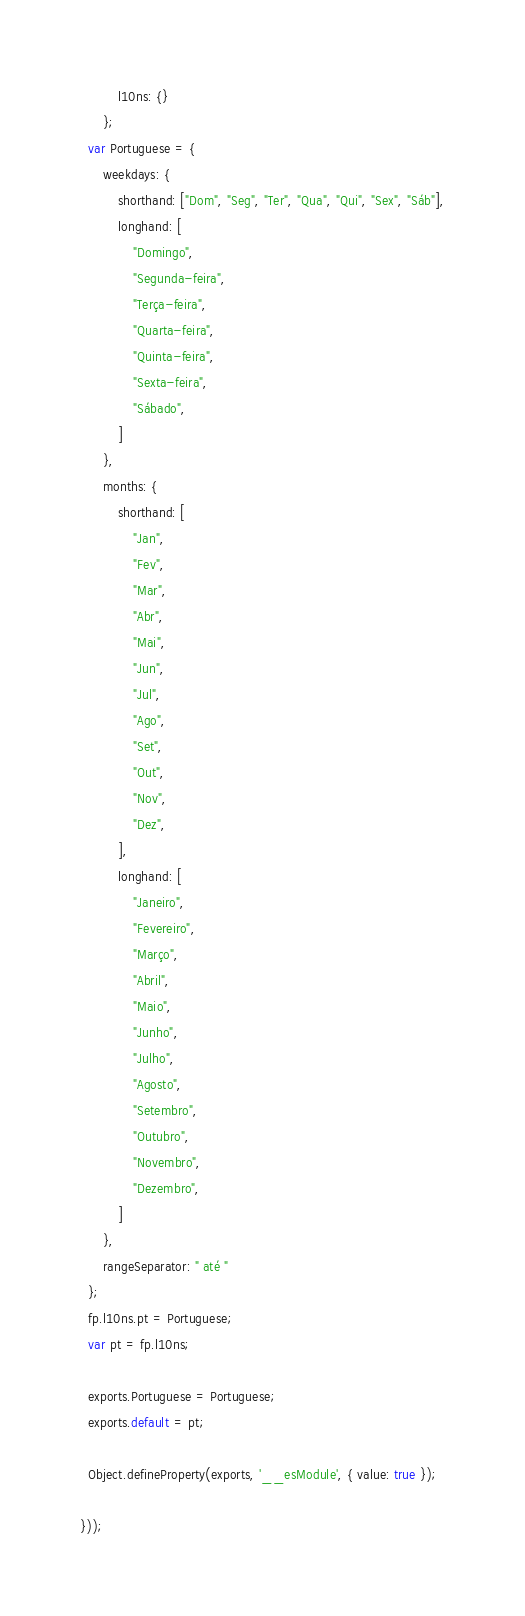<code> <loc_0><loc_0><loc_500><loc_500><_JavaScript_>          l10ns: {}
      };
  var Portuguese = {
      weekdays: {
          shorthand: ["Dom", "Seg", "Ter", "Qua", "Qui", "Sex", "Sáb"],
          longhand: [
              "Domingo",
              "Segunda-feira",
              "Terça-feira",
              "Quarta-feira",
              "Quinta-feira",
              "Sexta-feira",
              "Sábado",
          ]
      },
      months: {
          shorthand: [
              "Jan",
              "Fev",
              "Mar",
              "Abr",
              "Mai",
              "Jun",
              "Jul",
              "Ago",
              "Set",
              "Out",
              "Nov",
              "Dez",
          ],
          longhand: [
              "Janeiro",
              "Fevereiro",
              "Março",
              "Abril",
              "Maio",
              "Junho",
              "Julho",
              "Agosto",
              "Setembro",
              "Outubro",
              "Novembro",
              "Dezembro",
          ]
      },
      rangeSeparator: " até "
  };
  fp.l10ns.pt = Portuguese;
  var pt = fp.l10ns;

  exports.Portuguese = Portuguese;
  exports.default = pt;

  Object.defineProperty(exports, '__esModule', { value: true });

}));
</code> 